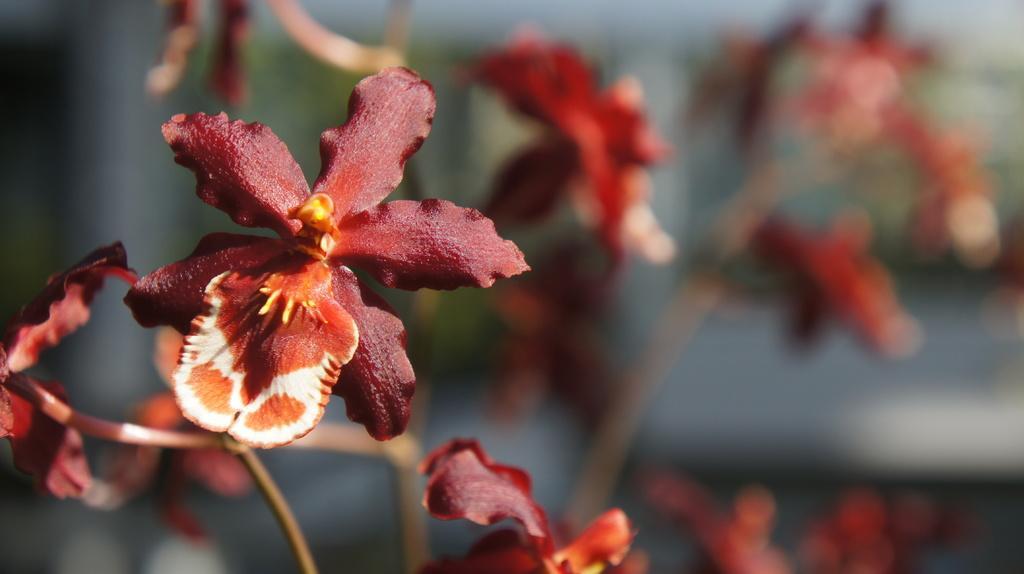Please provide a concise description of this image. In the image we can see flowers, brown, pale brown and white in color. And the background is blurred. 